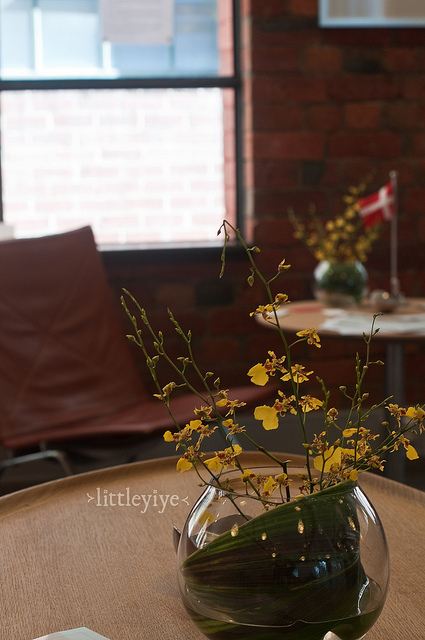Read and extract the text from this image. littleyiye 